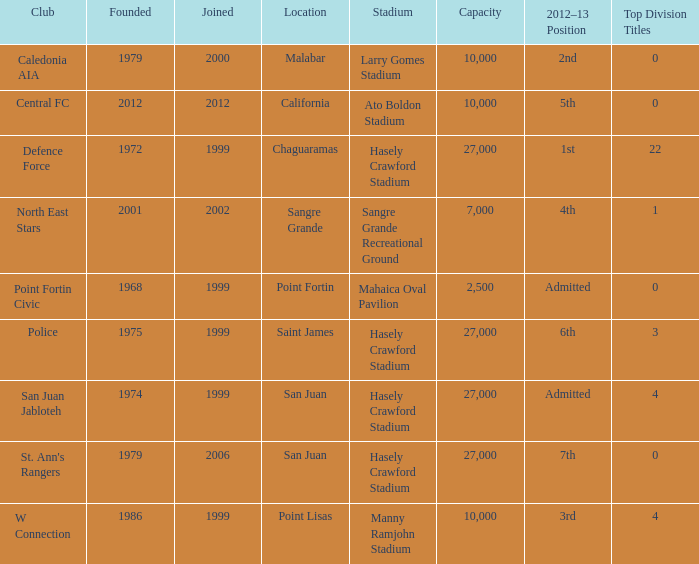What was the total number of Top Division Titles where the year founded was prior to 1975 and the location was in Chaguaramas? 22.0. 